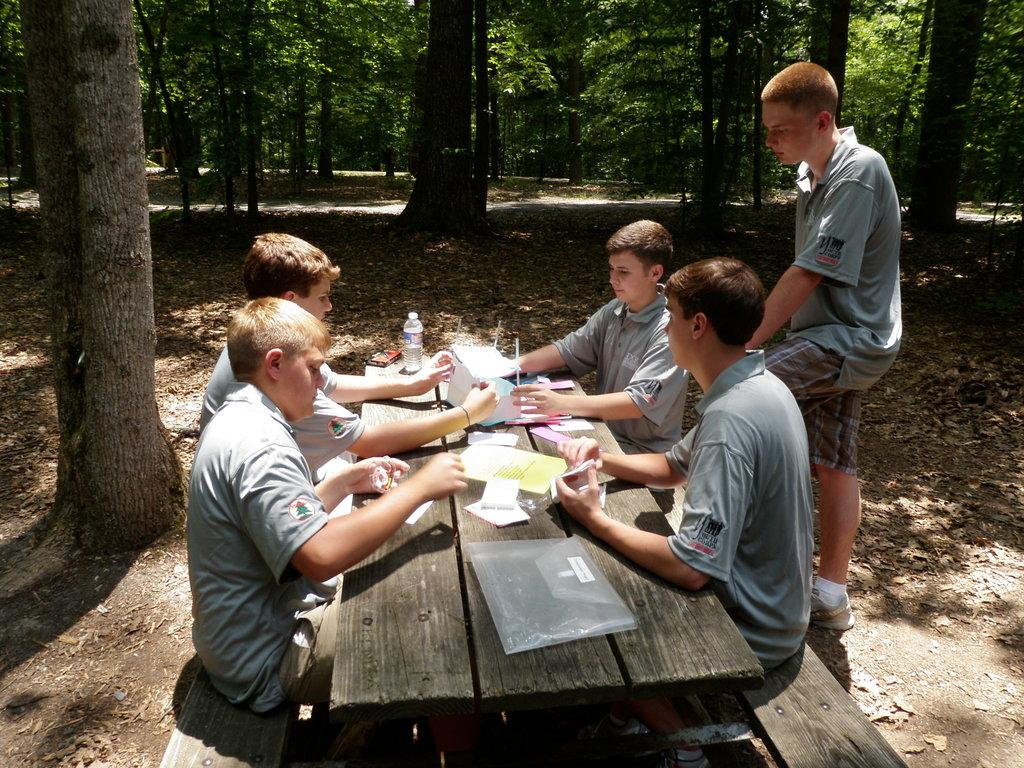How many people are seated in front of the table in the image? There are four people sitting in front of the table in the image. What is the position of the fifth person in the image? One person is standing in the image. What items can be seen on the table? There are papers and bottles on the table in the image. What can be seen in the background of the image? There are trees in the background of the image. What type of pen is the person using to make a statement in the image? There is no pen or statement being made in the image; it only shows people sitting and standing around a table with papers and bottles. 